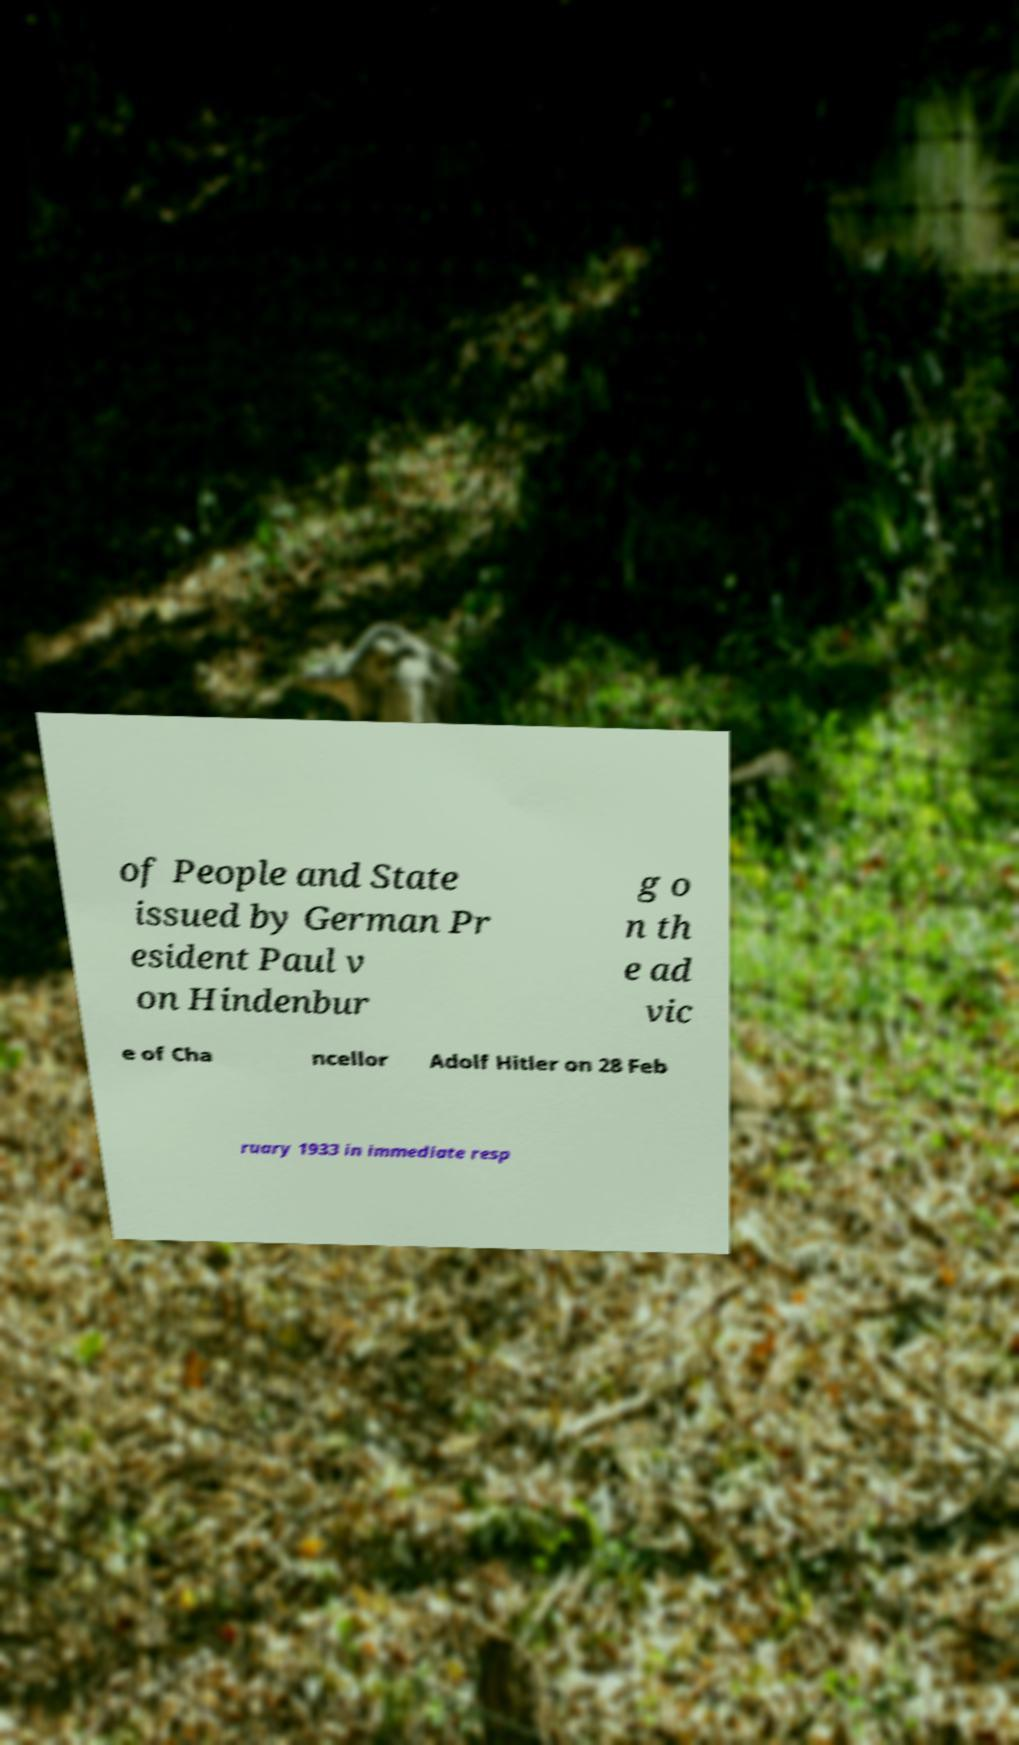Could you assist in decoding the text presented in this image and type it out clearly? of People and State issued by German Pr esident Paul v on Hindenbur g o n th e ad vic e of Cha ncellor Adolf Hitler on 28 Feb ruary 1933 in immediate resp 